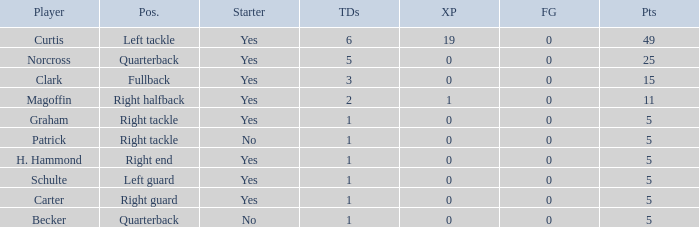Name the number of field goals for 19 extra points 1.0. 